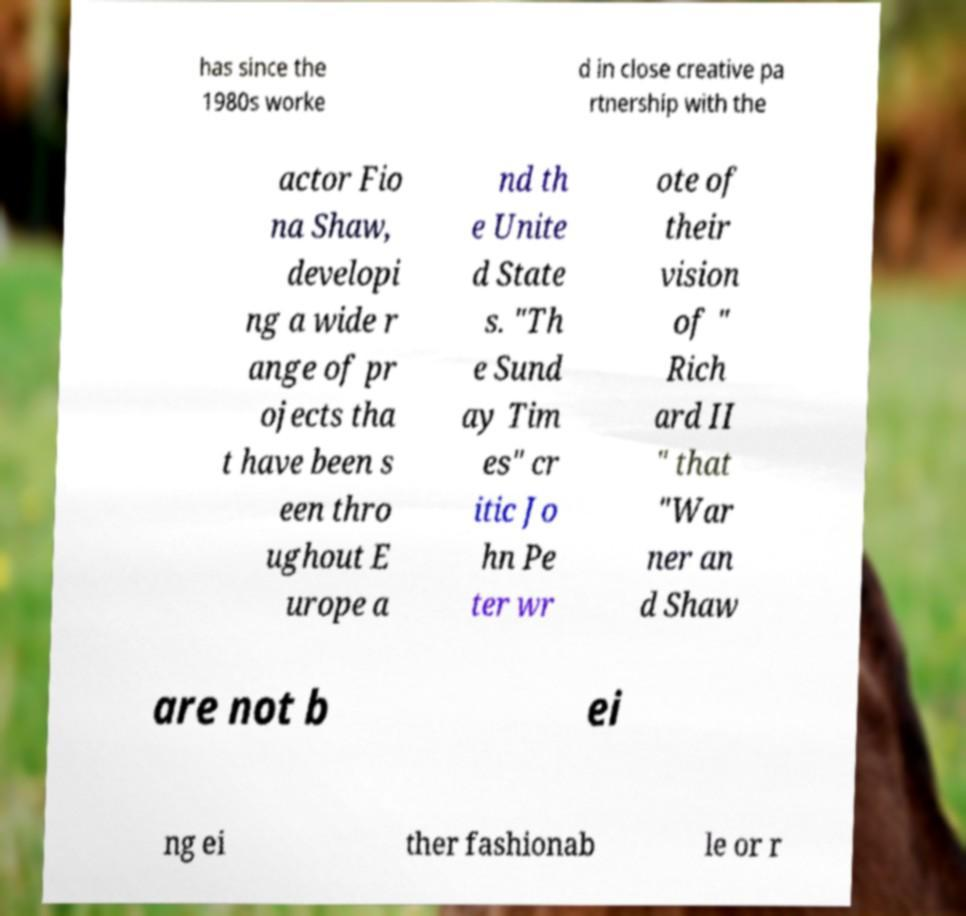What messages or text are displayed in this image? I need them in a readable, typed format. has since the 1980s worke d in close creative pa rtnership with the actor Fio na Shaw, developi ng a wide r ange of pr ojects tha t have been s een thro ughout E urope a nd th e Unite d State s. "Th e Sund ay Tim es" cr itic Jo hn Pe ter wr ote of their vision of " Rich ard II " that "War ner an d Shaw are not b ei ng ei ther fashionab le or r 